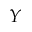Convert formula to latex. <formula><loc_0><loc_0><loc_500><loc_500>Y</formula> 